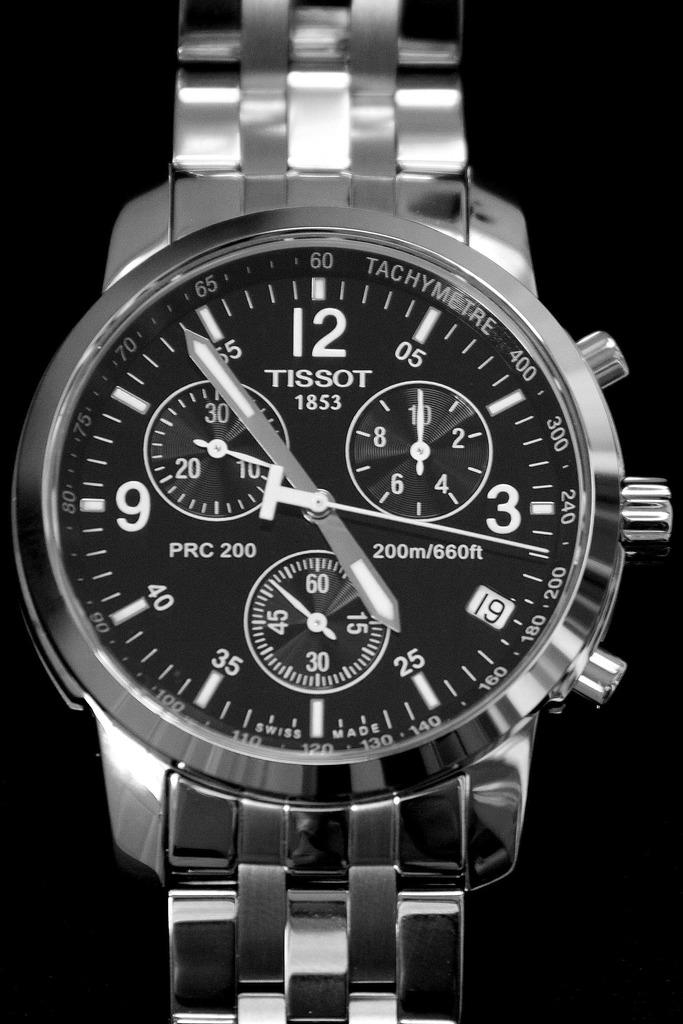<image>
Describe the image concisely. A very nice Tissot watch that is aluminum in nature 